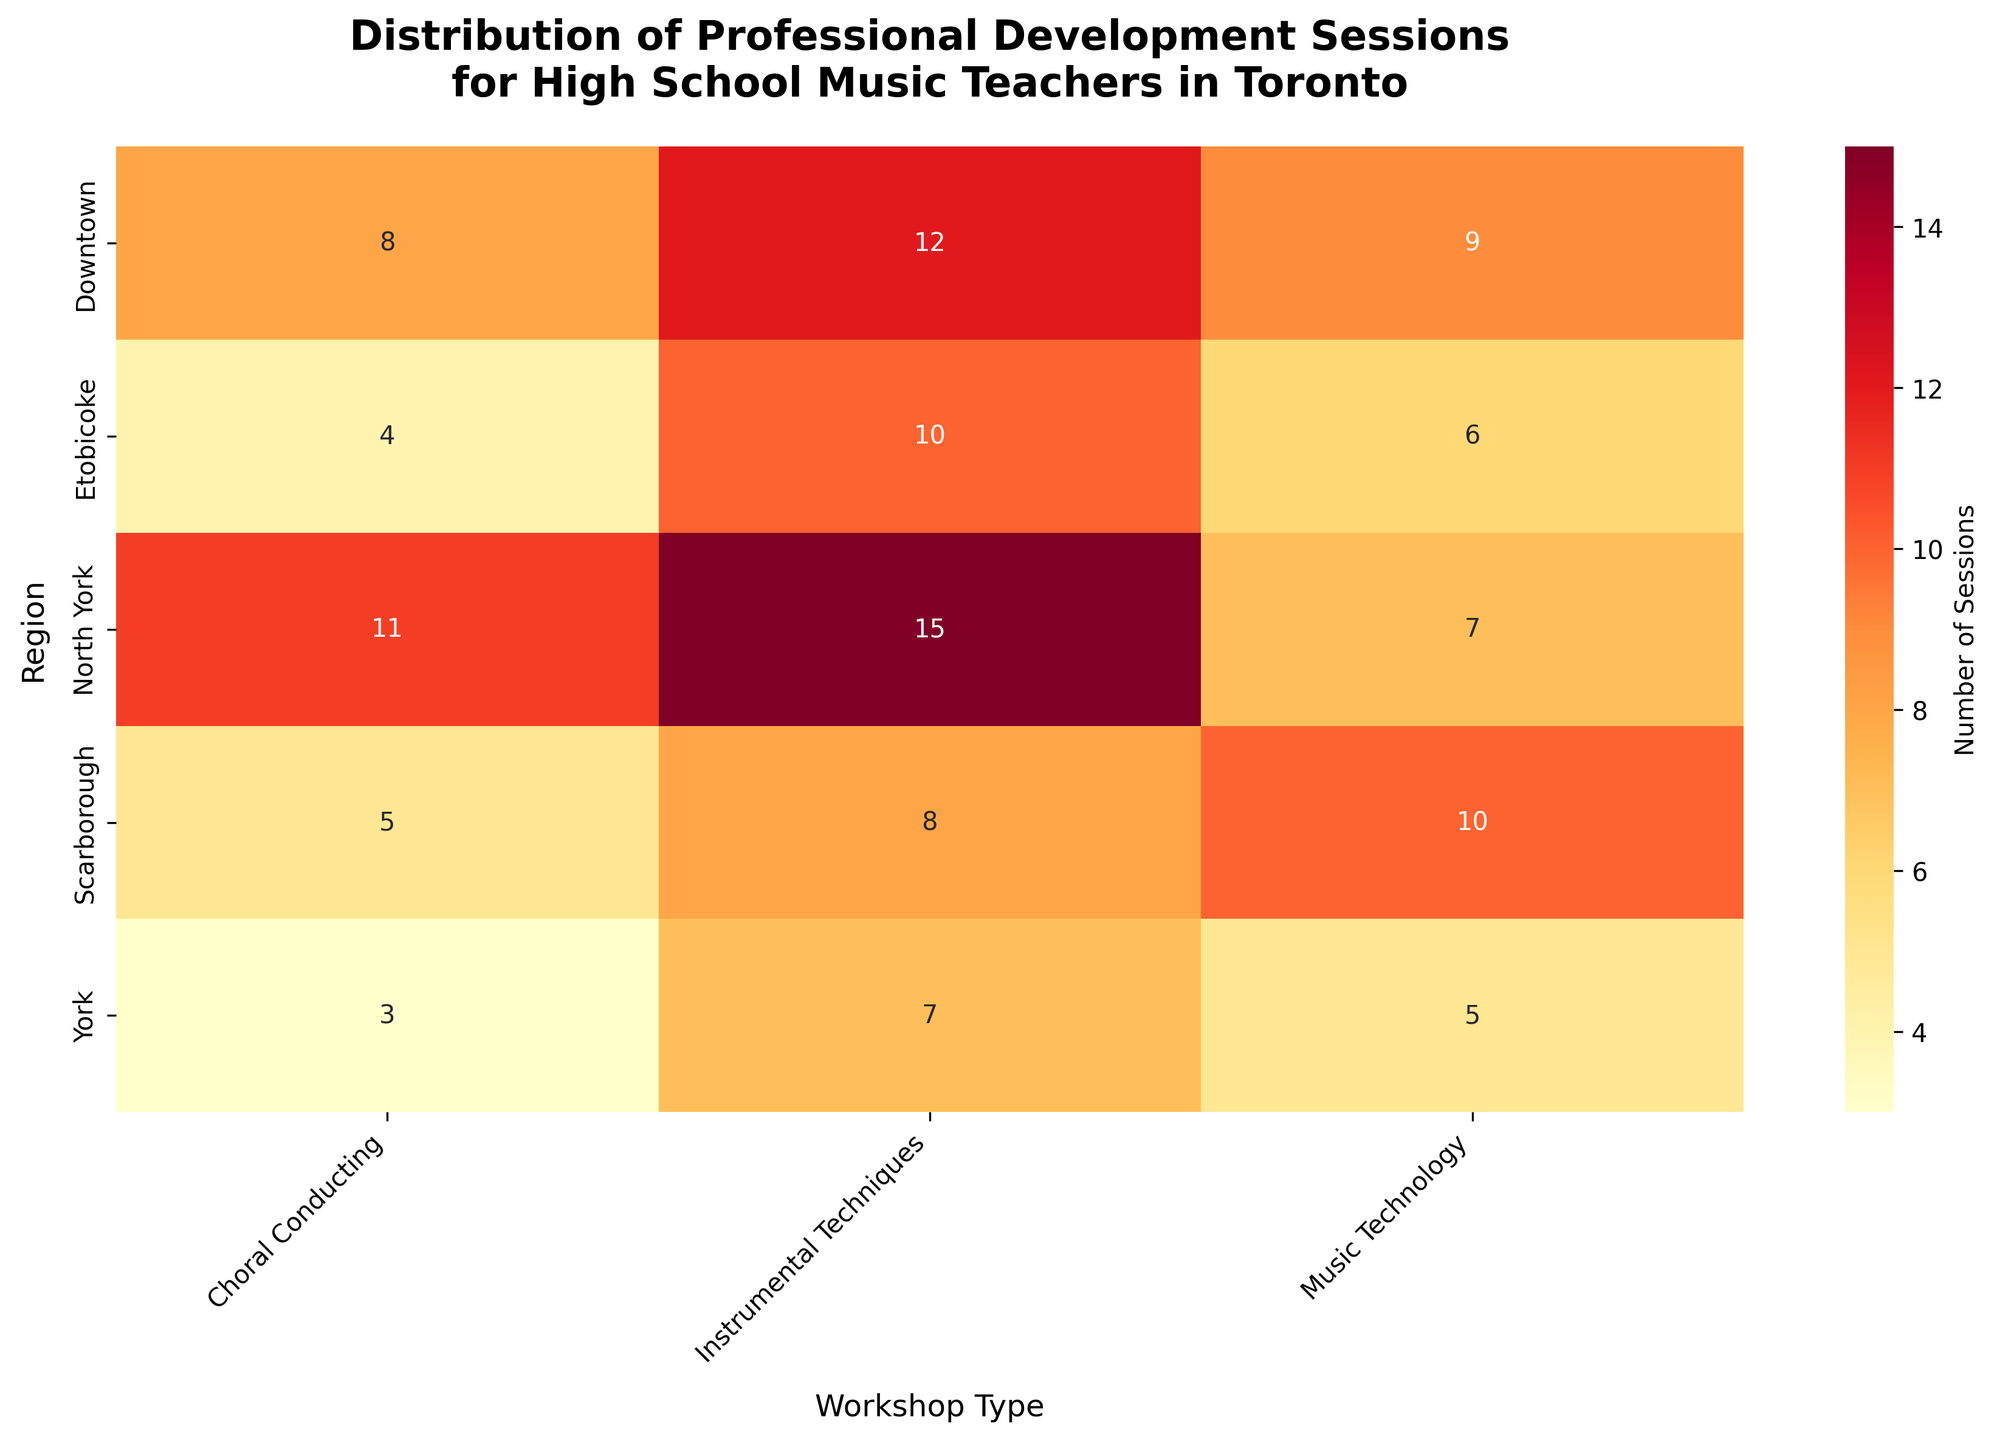What is the total number of sessions for Instrumental Techniques across all regions? First, find the number of Instrumental Techniques sessions for each region. Sum these values: 12 (Downtown) + 15 (North York) + 10 (Etobicoke) + 8 (Scarborough) + 7 (York) = 52.
Answer: 52 Which region has the highest number of Music Technology sessions? Compare the number of Music Technology sessions in each region: Downtown (9), North York (7), Etobicoke (6), Scarborough (10), and York (5). Scarborough has the highest number.
Answer: Scarborough How many more Choral Conducting sessions were held in North York compared to York? Find the number of Choral Conducting sessions in North York (11) and York (3). Subtract the number in York from the number in North York: 11 - 3 = 8.
Answer: 8 Which workshop type has the most sessions in Downtown? Compare the number of sessions for Instrumental Techniques (12), Choral Conducting (8), and Music Technology (9) in Downtown. Instrumental Techniques has the most sessions.
Answer: Instrumental Techniques What is the average number of sessions per workshop type in Etobicoke? List the number of sessions in Etobicoke: Instrumental Techniques (10), Choral Conducting (4), and Music Technology (6). Find the average: (10 + 4 + 6) / 3 = 20 / 3 ≈ 6.67.
Answer: Approximately 6.67 Which region has the lowest total number of sessions across all workshop types? Calculate the total number of sessions for each region. Downtown: 12 + 8 + 9 = 29; North York: 15 + 11 + 7 = 33; Etobicoke: 10 + 4 + 6 = 20; Scarborough: 8 + 5 + 10 = 23; York: 7 + 3 + 5 = 15. York has the lowest total.
Answer: York How many total Choral Conducting sessions are there across all regions? Add the number of Choral Conducting sessions in each region: Downtown (8), North York (11), Etobicoke (4), Scarborough (5), and York (3). The total is 8 + 11 + 4 + 5 + 3 = 31.
Answer: 31 Which region has more Instrumental Techniques sessions, Downtown or North York? Compare the number of Instrumental Techniques sessions in Downtown (12) and North York (15). North York has more.
Answer: North York What is the combined number of sessions for Choral Conducting and Music Technology in Scarborough? Add the number of Choral Conducting sessions (5) and Music Technology sessions (10) in Scarborough: 5 + 10 = 15.
Answer: 15 